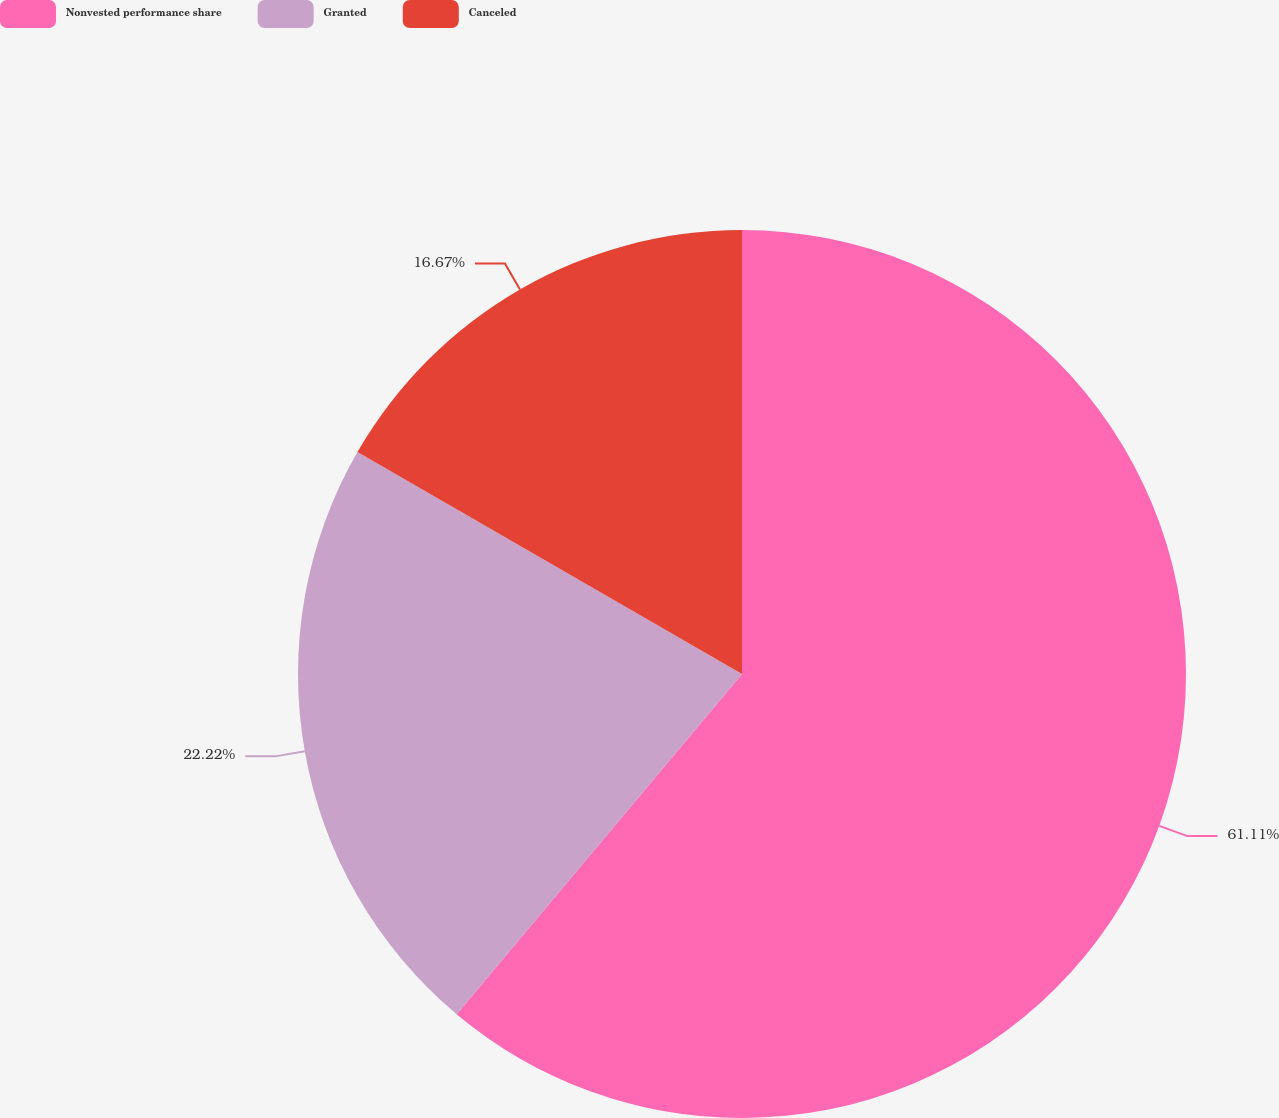Convert chart. <chart><loc_0><loc_0><loc_500><loc_500><pie_chart><fcel>Nonvested performance share<fcel>Granted<fcel>Canceled<nl><fcel>61.11%<fcel>22.22%<fcel>16.67%<nl></chart> 